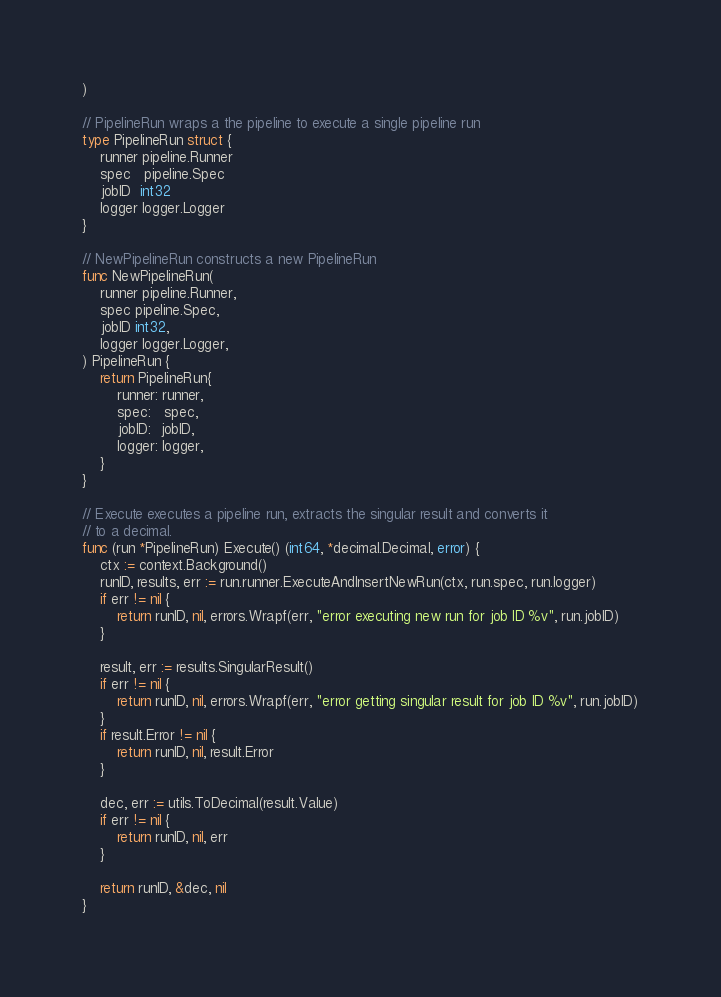Convert code to text. <code><loc_0><loc_0><loc_500><loc_500><_Go_>)

// PipelineRun wraps a the pipeline to execute a single pipeline run
type PipelineRun struct {
	runner pipeline.Runner
	spec   pipeline.Spec
	jobID  int32
	logger logger.Logger
}

// NewPipelineRun constructs a new PipelineRun
func NewPipelineRun(
	runner pipeline.Runner,
	spec pipeline.Spec,
	jobID int32,
	logger logger.Logger,
) PipelineRun {
	return PipelineRun{
		runner: runner,
		spec:   spec,
		jobID:  jobID,
		logger: logger,
	}
}

// Execute executes a pipeline run, extracts the singular result and converts it
// to a decimal.
func (run *PipelineRun) Execute() (int64, *decimal.Decimal, error) {
	ctx := context.Background()
	runID, results, err := run.runner.ExecuteAndInsertNewRun(ctx, run.spec, run.logger)
	if err != nil {
		return runID, nil, errors.Wrapf(err, "error executing new run for job ID %v", run.jobID)
	}

	result, err := results.SingularResult()
	if err != nil {
		return runID, nil, errors.Wrapf(err, "error getting singular result for job ID %v", run.jobID)
	}
	if result.Error != nil {
		return runID, nil, result.Error
	}

	dec, err := utils.ToDecimal(result.Value)
	if err != nil {
		return runID, nil, err
	}

	return runID, &dec, nil
}
</code> 